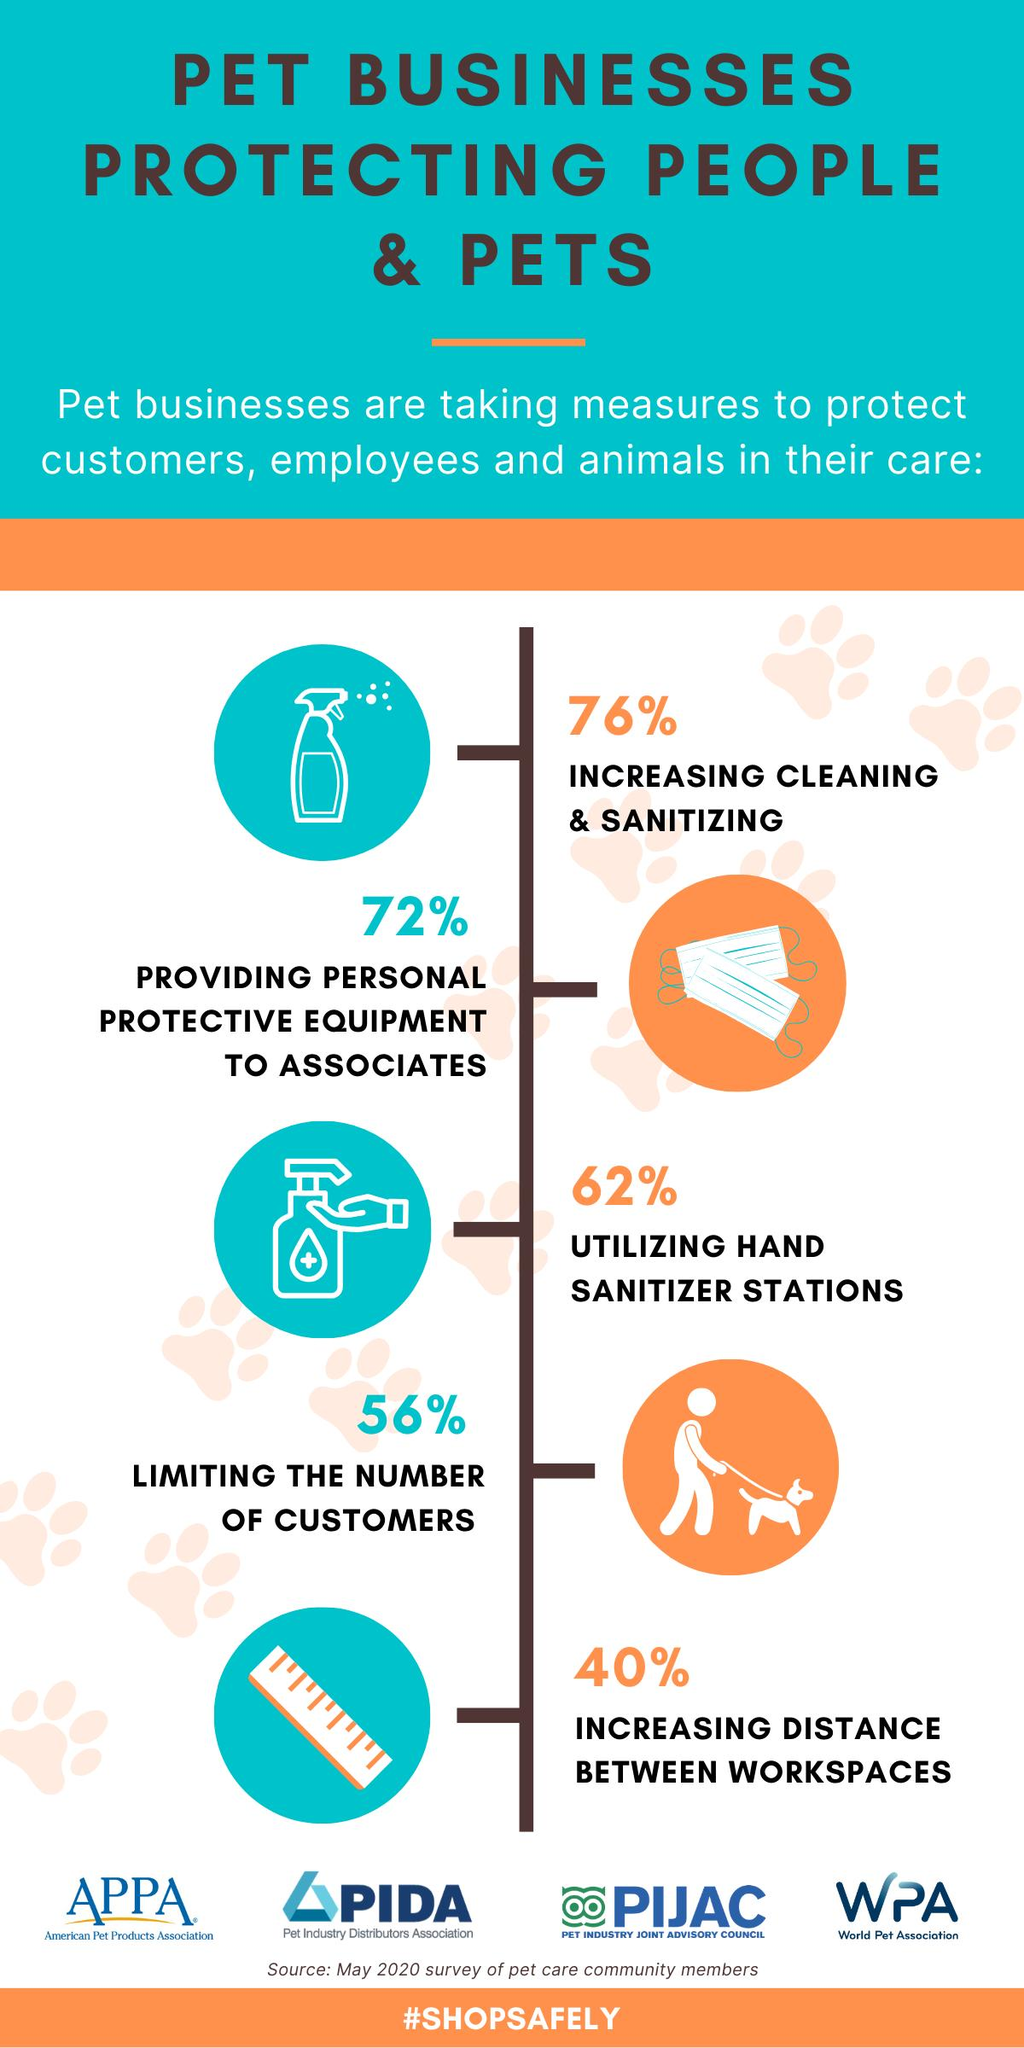Outline some significant characteristics in this image. According to a recent survey conducted by 40% of pet businesses, a common measure taken to improve employee satisfaction and productivity is increasing the distance between workspaces. Seventy-two percent of pet businesses provide protective equipment to their customers. Seventy-six percent of the businesses have reported an increase in cleaning and sanitizing efforts since implementing a comprehensive cleaning checklist program. 